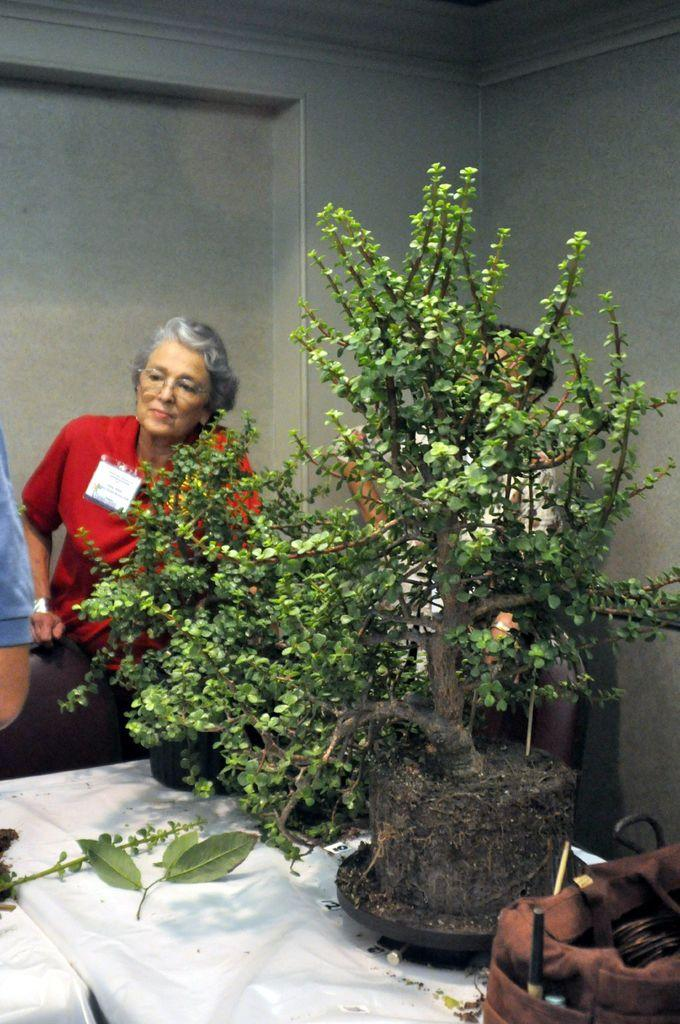What type of plants can be seen in the image? There are houseplants in the image. What is located on the table in the image? There are objects on a table in the image. How many people are present in the image? There are three persons in the image. What can be seen in the background of the image? There is a wall visible in the background of the image. Where might this image have been taken? The image may have been taken in a hall. What type of current can be seen flowing through the houseplants in the image? There is no current flowing through the houseplants in the image; they are stationary plants. How does the addition of a fourth person change the dynamics of the image? There is no fourth person present in the image, so their addition would not change the dynamics. 